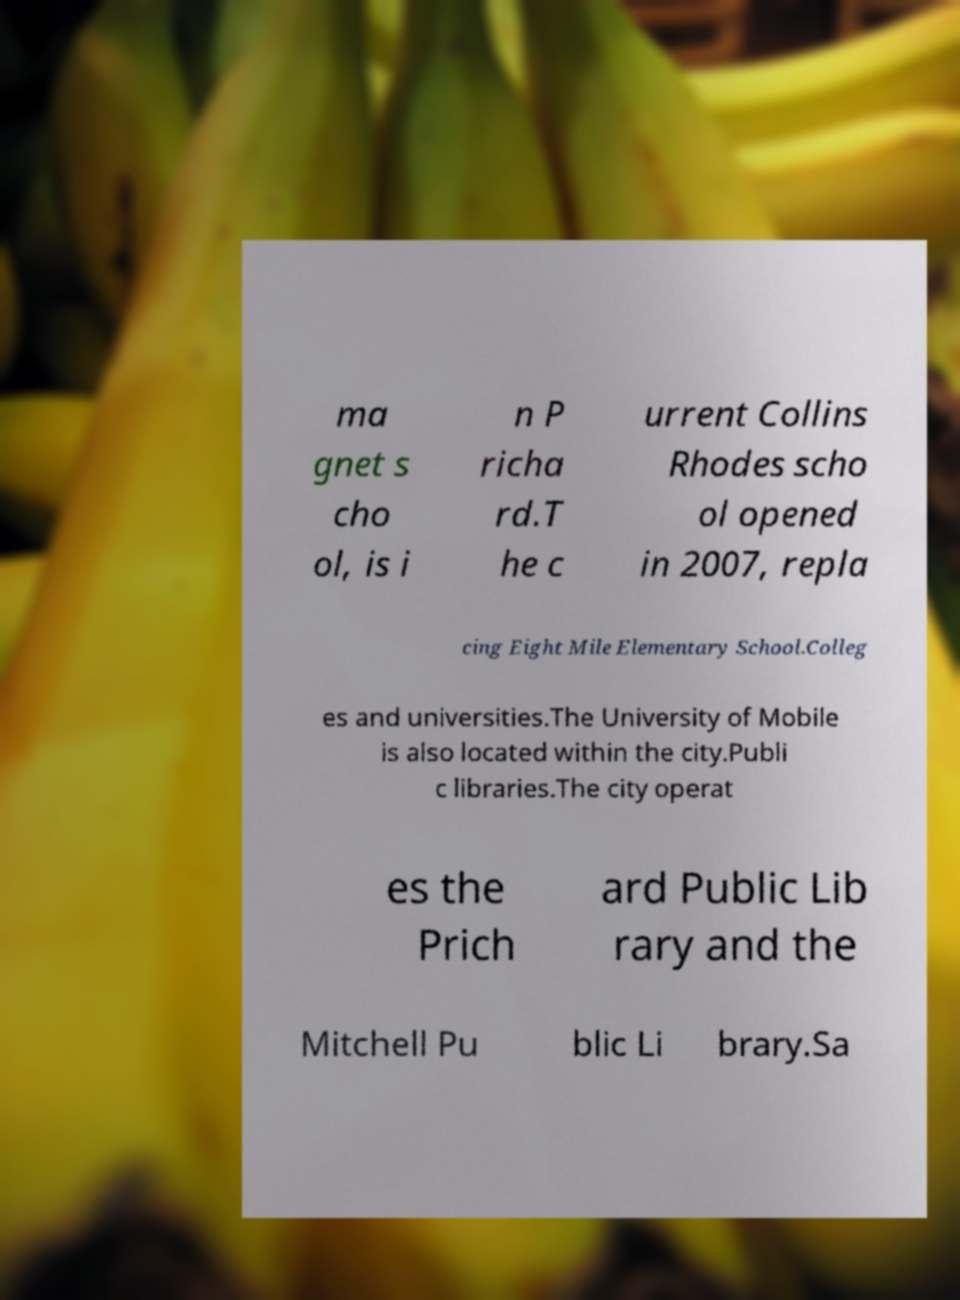Please identify and transcribe the text found in this image. ma gnet s cho ol, is i n P richa rd.T he c urrent Collins Rhodes scho ol opened in 2007, repla cing Eight Mile Elementary School.Colleg es and universities.The University of Mobile is also located within the city.Publi c libraries.The city operat es the Prich ard Public Lib rary and the Mitchell Pu blic Li brary.Sa 